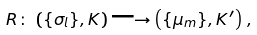<formula> <loc_0><loc_0><loc_500><loc_500>R \colon \, \left ( \{ { \sigma } _ { l } \} , { K } \right ) \longrightarrow \left ( \{ { \mu } _ { m } \} , { K } ^ { \prime } \right ) \, ,</formula> 